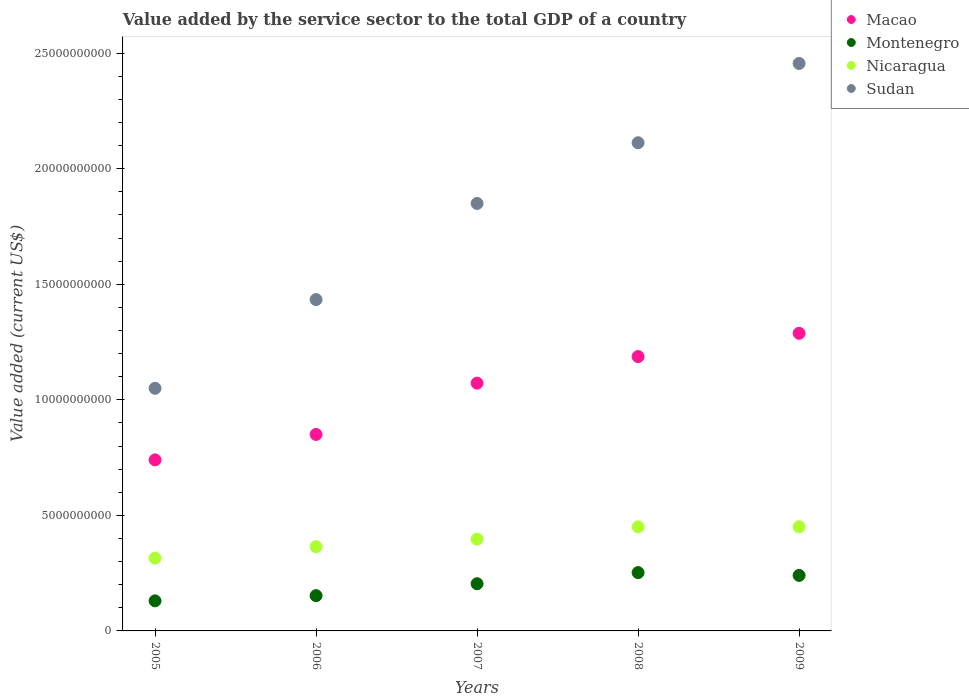How many different coloured dotlines are there?
Offer a very short reply. 4. What is the value added by the service sector to the total GDP in Sudan in 2009?
Keep it short and to the point. 2.46e+1. Across all years, what is the maximum value added by the service sector to the total GDP in Montenegro?
Provide a succinct answer. 2.52e+09. Across all years, what is the minimum value added by the service sector to the total GDP in Macao?
Ensure brevity in your answer.  7.40e+09. What is the total value added by the service sector to the total GDP in Nicaragua in the graph?
Your answer should be compact. 1.98e+1. What is the difference between the value added by the service sector to the total GDP in Nicaragua in 2005 and that in 2006?
Offer a terse response. -4.93e+08. What is the difference between the value added by the service sector to the total GDP in Nicaragua in 2006 and the value added by the service sector to the total GDP in Sudan in 2008?
Your answer should be very brief. -1.75e+1. What is the average value added by the service sector to the total GDP in Sudan per year?
Make the answer very short. 1.78e+1. In the year 2009, what is the difference between the value added by the service sector to the total GDP in Montenegro and value added by the service sector to the total GDP in Sudan?
Offer a terse response. -2.22e+1. In how many years, is the value added by the service sector to the total GDP in Sudan greater than 5000000000 US$?
Provide a short and direct response. 5. What is the ratio of the value added by the service sector to the total GDP in Sudan in 2005 to that in 2008?
Your answer should be compact. 0.5. Is the difference between the value added by the service sector to the total GDP in Montenegro in 2005 and 2006 greater than the difference between the value added by the service sector to the total GDP in Sudan in 2005 and 2006?
Ensure brevity in your answer.  Yes. What is the difference between the highest and the second highest value added by the service sector to the total GDP in Macao?
Give a very brief answer. 1.01e+09. What is the difference between the highest and the lowest value added by the service sector to the total GDP in Nicaragua?
Provide a succinct answer. 1.36e+09. In how many years, is the value added by the service sector to the total GDP in Nicaragua greater than the average value added by the service sector to the total GDP in Nicaragua taken over all years?
Offer a terse response. 3. Is the sum of the value added by the service sector to the total GDP in Sudan in 2006 and 2008 greater than the maximum value added by the service sector to the total GDP in Nicaragua across all years?
Your answer should be very brief. Yes. Is it the case that in every year, the sum of the value added by the service sector to the total GDP in Sudan and value added by the service sector to the total GDP in Macao  is greater than the sum of value added by the service sector to the total GDP in Montenegro and value added by the service sector to the total GDP in Nicaragua?
Your answer should be compact. No. Is it the case that in every year, the sum of the value added by the service sector to the total GDP in Montenegro and value added by the service sector to the total GDP in Nicaragua  is greater than the value added by the service sector to the total GDP in Sudan?
Provide a short and direct response. No. Is the value added by the service sector to the total GDP in Nicaragua strictly less than the value added by the service sector to the total GDP in Sudan over the years?
Offer a very short reply. Yes. What is the difference between two consecutive major ticks on the Y-axis?
Offer a terse response. 5.00e+09. Does the graph contain any zero values?
Provide a succinct answer. No. Does the graph contain grids?
Ensure brevity in your answer.  No. How many legend labels are there?
Make the answer very short. 4. How are the legend labels stacked?
Give a very brief answer. Vertical. What is the title of the graph?
Your response must be concise. Value added by the service sector to the total GDP of a country. What is the label or title of the Y-axis?
Offer a very short reply. Value added (current US$). What is the Value added (current US$) in Macao in 2005?
Offer a terse response. 7.40e+09. What is the Value added (current US$) of Montenegro in 2005?
Make the answer very short. 1.30e+09. What is the Value added (current US$) of Nicaragua in 2005?
Your answer should be very brief. 3.15e+09. What is the Value added (current US$) of Sudan in 2005?
Your response must be concise. 1.05e+1. What is the Value added (current US$) in Macao in 2006?
Your answer should be compact. 8.50e+09. What is the Value added (current US$) of Montenegro in 2006?
Make the answer very short. 1.53e+09. What is the Value added (current US$) in Nicaragua in 2006?
Your answer should be compact. 3.64e+09. What is the Value added (current US$) of Sudan in 2006?
Offer a terse response. 1.43e+1. What is the Value added (current US$) in Macao in 2007?
Ensure brevity in your answer.  1.07e+1. What is the Value added (current US$) of Montenegro in 2007?
Your response must be concise. 2.04e+09. What is the Value added (current US$) of Nicaragua in 2007?
Offer a very short reply. 3.97e+09. What is the Value added (current US$) of Sudan in 2007?
Ensure brevity in your answer.  1.85e+1. What is the Value added (current US$) in Macao in 2008?
Provide a short and direct response. 1.19e+1. What is the Value added (current US$) of Montenegro in 2008?
Give a very brief answer. 2.52e+09. What is the Value added (current US$) of Nicaragua in 2008?
Your answer should be very brief. 4.50e+09. What is the Value added (current US$) in Sudan in 2008?
Provide a succinct answer. 2.11e+1. What is the Value added (current US$) in Macao in 2009?
Provide a succinct answer. 1.29e+1. What is the Value added (current US$) of Montenegro in 2009?
Make the answer very short. 2.40e+09. What is the Value added (current US$) in Nicaragua in 2009?
Provide a succinct answer. 4.51e+09. What is the Value added (current US$) of Sudan in 2009?
Keep it short and to the point. 2.46e+1. Across all years, what is the maximum Value added (current US$) in Macao?
Make the answer very short. 1.29e+1. Across all years, what is the maximum Value added (current US$) of Montenegro?
Your answer should be very brief. 2.52e+09. Across all years, what is the maximum Value added (current US$) in Nicaragua?
Provide a succinct answer. 4.51e+09. Across all years, what is the maximum Value added (current US$) in Sudan?
Keep it short and to the point. 2.46e+1. Across all years, what is the minimum Value added (current US$) of Macao?
Your answer should be compact. 7.40e+09. Across all years, what is the minimum Value added (current US$) in Montenegro?
Your answer should be compact. 1.30e+09. Across all years, what is the minimum Value added (current US$) in Nicaragua?
Provide a succinct answer. 3.15e+09. Across all years, what is the minimum Value added (current US$) in Sudan?
Ensure brevity in your answer.  1.05e+1. What is the total Value added (current US$) in Macao in the graph?
Keep it short and to the point. 5.14e+1. What is the total Value added (current US$) in Montenegro in the graph?
Give a very brief answer. 9.80e+09. What is the total Value added (current US$) of Nicaragua in the graph?
Give a very brief answer. 1.98e+1. What is the total Value added (current US$) of Sudan in the graph?
Offer a terse response. 8.90e+1. What is the difference between the Value added (current US$) in Macao in 2005 and that in 2006?
Provide a succinct answer. -1.10e+09. What is the difference between the Value added (current US$) in Montenegro in 2005 and that in 2006?
Provide a succinct answer. -2.25e+08. What is the difference between the Value added (current US$) in Nicaragua in 2005 and that in 2006?
Make the answer very short. -4.93e+08. What is the difference between the Value added (current US$) in Sudan in 2005 and that in 2006?
Keep it short and to the point. -3.84e+09. What is the difference between the Value added (current US$) in Macao in 2005 and that in 2007?
Your response must be concise. -3.32e+09. What is the difference between the Value added (current US$) of Montenegro in 2005 and that in 2007?
Your answer should be compact. -7.41e+08. What is the difference between the Value added (current US$) of Nicaragua in 2005 and that in 2007?
Keep it short and to the point. -8.19e+08. What is the difference between the Value added (current US$) of Sudan in 2005 and that in 2007?
Provide a short and direct response. -8.00e+09. What is the difference between the Value added (current US$) in Macao in 2005 and that in 2008?
Offer a terse response. -4.47e+09. What is the difference between the Value added (current US$) of Montenegro in 2005 and that in 2008?
Offer a very short reply. -1.22e+09. What is the difference between the Value added (current US$) of Nicaragua in 2005 and that in 2008?
Your answer should be very brief. -1.35e+09. What is the difference between the Value added (current US$) of Sudan in 2005 and that in 2008?
Keep it short and to the point. -1.06e+1. What is the difference between the Value added (current US$) in Macao in 2005 and that in 2009?
Your response must be concise. -5.48e+09. What is the difference between the Value added (current US$) of Montenegro in 2005 and that in 2009?
Keep it short and to the point. -1.10e+09. What is the difference between the Value added (current US$) in Nicaragua in 2005 and that in 2009?
Provide a short and direct response. -1.36e+09. What is the difference between the Value added (current US$) of Sudan in 2005 and that in 2009?
Your answer should be compact. -1.41e+1. What is the difference between the Value added (current US$) in Macao in 2006 and that in 2007?
Your response must be concise. -2.22e+09. What is the difference between the Value added (current US$) of Montenegro in 2006 and that in 2007?
Give a very brief answer. -5.16e+08. What is the difference between the Value added (current US$) of Nicaragua in 2006 and that in 2007?
Your answer should be compact. -3.26e+08. What is the difference between the Value added (current US$) in Sudan in 2006 and that in 2007?
Give a very brief answer. -4.16e+09. What is the difference between the Value added (current US$) of Macao in 2006 and that in 2008?
Make the answer very short. -3.37e+09. What is the difference between the Value added (current US$) of Montenegro in 2006 and that in 2008?
Give a very brief answer. -9.96e+08. What is the difference between the Value added (current US$) of Nicaragua in 2006 and that in 2008?
Your response must be concise. -8.58e+08. What is the difference between the Value added (current US$) of Sudan in 2006 and that in 2008?
Give a very brief answer. -6.79e+09. What is the difference between the Value added (current US$) in Macao in 2006 and that in 2009?
Give a very brief answer. -4.38e+09. What is the difference between the Value added (current US$) of Montenegro in 2006 and that in 2009?
Provide a succinct answer. -8.76e+08. What is the difference between the Value added (current US$) of Nicaragua in 2006 and that in 2009?
Give a very brief answer. -8.62e+08. What is the difference between the Value added (current US$) of Sudan in 2006 and that in 2009?
Provide a short and direct response. -1.02e+1. What is the difference between the Value added (current US$) of Macao in 2007 and that in 2008?
Offer a terse response. -1.15e+09. What is the difference between the Value added (current US$) in Montenegro in 2007 and that in 2008?
Offer a terse response. -4.80e+08. What is the difference between the Value added (current US$) in Nicaragua in 2007 and that in 2008?
Give a very brief answer. -5.32e+08. What is the difference between the Value added (current US$) of Sudan in 2007 and that in 2008?
Provide a short and direct response. -2.63e+09. What is the difference between the Value added (current US$) of Macao in 2007 and that in 2009?
Provide a succinct answer. -2.16e+09. What is the difference between the Value added (current US$) in Montenegro in 2007 and that in 2009?
Your response must be concise. -3.60e+08. What is the difference between the Value added (current US$) in Nicaragua in 2007 and that in 2009?
Offer a terse response. -5.36e+08. What is the difference between the Value added (current US$) in Sudan in 2007 and that in 2009?
Ensure brevity in your answer.  -6.06e+09. What is the difference between the Value added (current US$) of Macao in 2008 and that in 2009?
Offer a very short reply. -1.01e+09. What is the difference between the Value added (current US$) in Montenegro in 2008 and that in 2009?
Provide a succinct answer. 1.20e+08. What is the difference between the Value added (current US$) in Nicaragua in 2008 and that in 2009?
Provide a succinct answer. -3.93e+06. What is the difference between the Value added (current US$) in Sudan in 2008 and that in 2009?
Keep it short and to the point. -3.43e+09. What is the difference between the Value added (current US$) in Macao in 2005 and the Value added (current US$) in Montenegro in 2006?
Make the answer very short. 5.87e+09. What is the difference between the Value added (current US$) in Macao in 2005 and the Value added (current US$) in Nicaragua in 2006?
Keep it short and to the point. 3.76e+09. What is the difference between the Value added (current US$) in Macao in 2005 and the Value added (current US$) in Sudan in 2006?
Provide a succinct answer. -6.94e+09. What is the difference between the Value added (current US$) in Montenegro in 2005 and the Value added (current US$) in Nicaragua in 2006?
Your answer should be compact. -2.34e+09. What is the difference between the Value added (current US$) in Montenegro in 2005 and the Value added (current US$) in Sudan in 2006?
Ensure brevity in your answer.  -1.30e+1. What is the difference between the Value added (current US$) in Nicaragua in 2005 and the Value added (current US$) in Sudan in 2006?
Your answer should be very brief. -1.12e+1. What is the difference between the Value added (current US$) in Macao in 2005 and the Value added (current US$) in Montenegro in 2007?
Make the answer very short. 5.36e+09. What is the difference between the Value added (current US$) of Macao in 2005 and the Value added (current US$) of Nicaragua in 2007?
Ensure brevity in your answer.  3.43e+09. What is the difference between the Value added (current US$) of Macao in 2005 and the Value added (current US$) of Sudan in 2007?
Your answer should be compact. -1.11e+1. What is the difference between the Value added (current US$) in Montenegro in 2005 and the Value added (current US$) in Nicaragua in 2007?
Offer a very short reply. -2.67e+09. What is the difference between the Value added (current US$) in Montenegro in 2005 and the Value added (current US$) in Sudan in 2007?
Your answer should be compact. -1.72e+1. What is the difference between the Value added (current US$) in Nicaragua in 2005 and the Value added (current US$) in Sudan in 2007?
Ensure brevity in your answer.  -1.53e+1. What is the difference between the Value added (current US$) of Macao in 2005 and the Value added (current US$) of Montenegro in 2008?
Ensure brevity in your answer.  4.88e+09. What is the difference between the Value added (current US$) in Macao in 2005 and the Value added (current US$) in Nicaragua in 2008?
Your answer should be very brief. 2.90e+09. What is the difference between the Value added (current US$) of Macao in 2005 and the Value added (current US$) of Sudan in 2008?
Your response must be concise. -1.37e+1. What is the difference between the Value added (current US$) in Montenegro in 2005 and the Value added (current US$) in Nicaragua in 2008?
Your response must be concise. -3.20e+09. What is the difference between the Value added (current US$) of Montenegro in 2005 and the Value added (current US$) of Sudan in 2008?
Provide a succinct answer. -1.98e+1. What is the difference between the Value added (current US$) in Nicaragua in 2005 and the Value added (current US$) in Sudan in 2008?
Ensure brevity in your answer.  -1.80e+1. What is the difference between the Value added (current US$) of Macao in 2005 and the Value added (current US$) of Montenegro in 2009?
Offer a very short reply. 5.00e+09. What is the difference between the Value added (current US$) in Macao in 2005 and the Value added (current US$) in Nicaragua in 2009?
Keep it short and to the point. 2.89e+09. What is the difference between the Value added (current US$) in Macao in 2005 and the Value added (current US$) in Sudan in 2009?
Provide a succinct answer. -1.72e+1. What is the difference between the Value added (current US$) of Montenegro in 2005 and the Value added (current US$) of Nicaragua in 2009?
Your response must be concise. -3.21e+09. What is the difference between the Value added (current US$) in Montenegro in 2005 and the Value added (current US$) in Sudan in 2009?
Keep it short and to the point. -2.33e+1. What is the difference between the Value added (current US$) in Nicaragua in 2005 and the Value added (current US$) in Sudan in 2009?
Your answer should be compact. -2.14e+1. What is the difference between the Value added (current US$) in Macao in 2006 and the Value added (current US$) in Montenegro in 2007?
Offer a very short reply. 6.46e+09. What is the difference between the Value added (current US$) of Macao in 2006 and the Value added (current US$) of Nicaragua in 2007?
Provide a short and direct response. 4.53e+09. What is the difference between the Value added (current US$) in Macao in 2006 and the Value added (current US$) in Sudan in 2007?
Ensure brevity in your answer.  -1.00e+1. What is the difference between the Value added (current US$) in Montenegro in 2006 and the Value added (current US$) in Nicaragua in 2007?
Offer a very short reply. -2.44e+09. What is the difference between the Value added (current US$) of Montenegro in 2006 and the Value added (current US$) of Sudan in 2007?
Provide a succinct answer. -1.70e+1. What is the difference between the Value added (current US$) of Nicaragua in 2006 and the Value added (current US$) of Sudan in 2007?
Your answer should be compact. -1.49e+1. What is the difference between the Value added (current US$) in Macao in 2006 and the Value added (current US$) in Montenegro in 2008?
Your response must be concise. 5.98e+09. What is the difference between the Value added (current US$) of Macao in 2006 and the Value added (current US$) of Nicaragua in 2008?
Provide a short and direct response. 4.00e+09. What is the difference between the Value added (current US$) of Macao in 2006 and the Value added (current US$) of Sudan in 2008?
Make the answer very short. -1.26e+1. What is the difference between the Value added (current US$) in Montenegro in 2006 and the Value added (current US$) in Nicaragua in 2008?
Your answer should be very brief. -2.98e+09. What is the difference between the Value added (current US$) in Montenegro in 2006 and the Value added (current US$) in Sudan in 2008?
Ensure brevity in your answer.  -1.96e+1. What is the difference between the Value added (current US$) in Nicaragua in 2006 and the Value added (current US$) in Sudan in 2008?
Make the answer very short. -1.75e+1. What is the difference between the Value added (current US$) in Macao in 2006 and the Value added (current US$) in Montenegro in 2009?
Provide a succinct answer. 6.10e+09. What is the difference between the Value added (current US$) in Macao in 2006 and the Value added (current US$) in Nicaragua in 2009?
Give a very brief answer. 4.00e+09. What is the difference between the Value added (current US$) in Macao in 2006 and the Value added (current US$) in Sudan in 2009?
Ensure brevity in your answer.  -1.61e+1. What is the difference between the Value added (current US$) of Montenegro in 2006 and the Value added (current US$) of Nicaragua in 2009?
Give a very brief answer. -2.98e+09. What is the difference between the Value added (current US$) in Montenegro in 2006 and the Value added (current US$) in Sudan in 2009?
Provide a succinct answer. -2.30e+1. What is the difference between the Value added (current US$) in Nicaragua in 2006 and the Value added (current US$) in Sudan in 2009?
Your answer should be very brief. -2.09e+1. What is the difference between the Value added (current US$) of Macao in 2007 and the Value added (current US$) of Montenegro in 2008?
Provide a short and direct response. 8.20e+09. What is the difference between the Value added (current US$) of Macao in 2007 and the Value added (current US$) of Nicaragua in 2008?
Keep it short and to the point. 6.22e+09. What is the difference between the Value added (current US$) in Macao in 2007 and the Value added (current US$) in Sudan in 2008?
Your response must be concise. -1.04e+1. What is the difference between the Value added (current US$) of Montenegro in 2007 and the Value added (current US$) of Nicaragua in 2008?
Your response must be concise. -2.46e+09. What is the difference between the Value added (current US$) in Montenegro in 2007 and the Value added (current US$) in Sudan in 2008?
Your answer should be very brief. -1.91e+1. What is the difference between the Value added (current US$) in Nicaragua in 2007 and the Value added (current US$) in Sudan in 2008?
Your answer should be compact. -1.72e+1. What is the difference between the Value added (current US$) in Macao in 2007 and the Value added (current US$) in Montenegro in 2009?
Your answer should be very brief. 8.32e+09. What is the difference between the Value added (current US$) in Macao in 2007 and the Value added (current US$) in Nicaragua in 2009?
Your answer should be very brief. 6.21e+09. What is the difference between the Value added (current US$) of Macao in 2007 and the Value added (current US$) of Sudan in 2009?
Make the answer very short. -1.38e+1. What is the difference between the Value added (current US$) in Montenegro in 2007 and the Value added (current US$) in Nicaragua in 2009?
Offer a very short reply. -2.46e+09. What is the difference between the Value added (current US$) in Montenegro in 2007 and the Value added (current US$) in Sudan in 2009?
Make the answer very short. -2.25e+1. What is the difference between the Value added (current US$) of Nicaragua in 2007 and the Value added (current US$) of Sudan in 2009?
Your answer should be compact. -2.06e+1. What is the difference between the Value added (current US$) in Macao in 2008 and the Value added (current US$) in Montenegro in 2009?
Your answer should be very brief. 9.47e+09. What is the difference between the Value added (current US$) of Macao in 2008 and the Value added (current US$) of Nicaragua in 2009?
Your response must be concise. 7.36e+09. What is the difference between the Value added (current US$) of Macao in 2008 and the Value added (current US$) of Sudan in 2009?
Keep it short and to the point. -1.27e+1. What is the difference between the Value added (current US$) in Montenegro in 2008 and the Value added (current US$) in Nicaragua in 2009?
Provide a succinct answer. -1.98e+09. What is the difference between the Value added (current US$) of Montenegro in 2008 and the Value added (current US$) of Sudan in 2009?
Provide a short and direct response. -2.20e+1. What is the difference between the Value added (current US$) of Nicaragua in 2008 and the Value added (current US$) of Sudan in 2009?
Offer a terse response. -2.01e+1. What is the average Value added (current US$) of Macao per year?
Give a very brief answer. 1.03e+1. What is the average Value added (current US$) in Montenegro per year?
Provide a succinct answer. 1.96e+09. What is the average Value added (current US$) in Nicaragua per year?
Your answer should be compact. 3.96e+09. What is the average Value added (current US$) in Sudan per year?
Offer a terse response. 1.78e+1. In the year 2005, what is the difference between the Value added (current US$) in Macao and Value added (current US$) in Montenegro?
Give a very brief answer. 6.10e+09. In the year 2005, what is the difference between the Value added (current US$) in Macao and Value added (current US$) in Nicaragua?
Offer a terse response. 4.25e+09. In the year 2005, what is the difference between the Value added (current US$) in Macao and Value added (current US$) in Sudan?
Your response must be concise. -3.10e+09. In the year 2005, what is the difference between the Value added (current US$) of Montenegro and Value added (current US$) of Nicaragua?
Offer a terse response. -1.85e+09. In the year 2005, what is the difference between the Value added (current US$) in Montenegro and Value added (current US$) in Sudan?
Keep it short and to the point. -9.20e+09. In the year 2005, what is the difference between the Value added (current US$) in Nicaragua and Value added (current US$) in Sudan?
Provide a succinct answer. -7.35e+09. In the year 2006, what is the difference between the Value added (current US$) of Macao and Value added (current US$) of Montenegro?
Keep it short and to the point. 6.98e+09. In the year 2006, what is the difference between the Value added (current US$) of Macao and Value added (current US$) of Nicaragua?
Keep it short and to the point. 4.86e+09. In the year 2006, what is the difference between the Value added (current US$) of Macao and Value added (current US$) of Sudan?
Your answer should be very brief. -5.84e+09. In the year 2006, what is the difference between the Value added (current US$) of Montenegro and Value added (current US$) of Nicaragua?
Offer a very short reply. -2.12e+09. In the year 2006, what is the difference between the Value added (current US$) of Montenegro and Value added (current US$) of Sudan?
Your answer should be very brief. -1.28e+1. In the year 2006, what is the difference between the Value added (current US$) of Nicaragua and Value added (current US$) of Sudan?
Your response must be concise. -1.07e+1. In the year 2007, what is the difference between the Value added (current US$) of Macao and Value added (current US$) of Montenegro?
Give a very brief answer. 8.68e+09. In the year 2007, what is the difference between the Value added (current US$) of Macao and Value added (current US$) of Nicaragua?
Provide a succinct answer. 6.75e+09. In the year 2007, what is the difference between the Value added (current US$) of Macao and Value added (current US$) of Sudan?
Your answer should be compact. -7.78e+09. In the year 2007, what is the difference between the Value added (current US$) of Montenegro and Value added (current US$) of Nicaragua?
Your answer should be very brief. -1.93e+09. In the year 2007, what is the difference between the Value added (current US$) in Montenegro and Value added (current US$) in Sudan?
Your response must be concise. -1.65e+1. In the year 2007, what is the difference between the Value added (current US$) of Nicaragua and Value added (current US$) of Sudan?
Your answer should be compact. -1.45e+1. In the year 2008, what is the difference between the Value added (current US$) in Macao and Value added (current US$) in Montenegro?
Provide a short and direct response. 9.35e+09. In the year 2008, what is the difference between the Value added (current US$) in Macao and Value added (current US$) in Nicaragua?
Ensure brevity in your answer.  7.37e+09. In the year 2008, what is the difference between the Value added (current US$) of Macao and Value added (current US$) of Sudan?
Your response must be concise. -9.25e+09. In the year 2008, what is the difference between the Value added (current US$) of Montenegro and Value added (current US$) of Nicaragua?
Provide a succinct answer. -1.98e+09. In the year 2008, what is the difference between the Value added (current US$) of Montenegro and Value added (current US$) of Sudan?
Offer a terse response. -1.86e+1. In the year 2008, what is the difference between the Value added (current US$) of Nicaragua and Value added (current US$) of Sudan?
Your answer should be very brief. -1.66e+1. In the year 2009, what is the difference between the Value added (current US$) in Macao and Value added (current US$) in Montenegro?
Your answer should be very brief. 1.05e+1. In the year 2009, what is the difference between the Value added (current US$) in Macao and Value added (current US$) in Nicaragua?
Offer a very short reply. 8.37e+09. In the year 2009, what is the difference between the Value added (current US$) in Macao and Value added (current US$) in Sudan?
Your answer should be very brief. -1.17e+1. In the year 2009, what is the difference between the Value added (current US$) of Montenegro and Value added (current US$) of Nicaragua?
Provide a succinct answer. -2.10e+09. In the year 2009, what is the difference between the Value added (current US$) of Montenegro and Value added (current US$) of Sudan?
Your answer should be compact. -2.22e+1. In the year 2009, what is the difference between the Value added (current US$) of Nicaragua and Value added (current US$) of Sudan?
Ensure brevity in your answer.  -2.00e+1. What is the ratio of the Value added (current US$) of Macao in 2005 to that in 2006?
Offer a very short reply. 0.87. What is the ratio of the Value added (current US$) in Montenegro in 2005 to that in 2006?
Your answer should be compact. 0.85. What is the ratio of the Value added (current US$) of Nicaragua in 2005 to that in 2006?
Offer a terse response. 0.86. What is the ratio of the Value added (current US$) of Sudan in 2005 to that in 2006?
Offer a very short reply. 0.73. What is the ratio of the Value added (current US$) in Macao in 2005 to that in 2007?
Your answer should be very brief. 0.69. What is the ratio of the Value added (current US$) in Montenegro in 2005 to that in 2007?
Provide a succinct answer. 0.64. What is the ratio of the Value added (current US$) in Nicaragua in 2005 to that in 2007?
Provide a short and direct response. 0.79. What is the ratio of the Value added (current US$) of Sudan in 2005 to that in 2007?
Make the answer very short. 0.57. What is the ratio of the Value added (current US$) in Macao in 2005 to that in 2008?
Offer a very short reply. 0.62. What is the ratio of the Value added (current US$) of Montenegro in 2005 to that in 2008?
Your response must be concise. 0.52. What is the ratio of the Value added (current US$) in Nicaragua in 2005 to that in 2008?
Give a very brief answer. 0.7. What is the ratio of the Value added (current US$) in Sudan in 2005 to that in 2008?
Provide a short and direct response. 0.5. What is the ratio of the Value added (current US$) of Macao in 2005 to that in 2009?
Your response must be concise. 0.57. What is the ratio of the Value added (current US$) in Montenegro in 2005 to that in 2009?
Ensure brevity in your answer.  0.54. What is the ratio of the Value added (current US$) in Nicaragua in 2005 to that in 2009?
Offer a terse response. 0.7. What is the ratio of the Value added (current US$) in Sudan in 2005 to that in 2009?
Offer a very short reply. 0.43. What is the ratio of the Value added (current US$) in Macao in 2006 to that in 2007?
Your answer should be very brief. 0.79. What is the ratio of the Value added (current US$) of Montenegro in 2006 to that in 2007?
Ensure brevity in your answer.  0.75. What is the ratio of the Value added (current US$) in Nicaragua in 2006 to that in 2007?
Ensure brevity in your answer.  0.92. What is the ratio of the Value added (current US$) in Sudan in 2006 to that in 2007?
Offer a very short reply. 0.78. What is the ratio of the Value added (current US$) in Macao in 2006 to that in 2008?
Your response must be concise. 0.72. What is the ratio of the Value added (current US$) of Montenegro in 2006 to that in 2008?
Your response must be concise. 0.61. What is the ratio of the Value added (current US$) of Nicaragua in 2006 to that in 2008?
Your answer should be very brief. 0.81. What is the ratio of the Value added (current US$) of Sudan in 2006 to that in 2008?
Your answer should be compact. 0.68. What is the ratio of the Value added (current US$) of Macao in 2006 to that in 2009?
Give a very brief answer. 0.66. What is the ratio of the Value added (current US$) of Montenegro in 2006 to that in 2009?
Give a very brief answer. 0.64. What is the ratio of the Value added (current US$) of Nicaragua in 2006 to that in 2009?
Provide a short and direct response. 0.81. What is the ratio of the Value added (current US$) in Sudan in 2006 to that in 2009?
Keep it short and to the point. 0.58. What is the ratio of the Value added (current US$) in Macao in 2007 to that in 2008?
Keep it short and to the point. 0.9. What is the ratio of the Value added (current US$) of Montenegro in 2007 to that in 2008?
Offer a very short reply. 0.81. What is the ratio of the Value added (current US$) of Nicaragua in 2007 to that in 2008?
Your answer should be compact. 0.88. What is the ratio of the Value added (current US$) in Sudan in 2007 to that in 2008?
Your answer should be compact. 0.88. What is the ratio of the Value added (current US$) in Macao in 2007 to that in 2009?
Your answer should be very brief. 0.83. What is the ratio of the Value added (current US$) of Montenegro in 2007 to that in 2009?
Keep it short and to the point. 0.85. What is the ratio of the Value added (current US$) of Nicaragua in 2007 to that in 2009?
Give a very brief answer. 0.88. What is the ratio of the Value added (current US$) of Sudan in 2007 to that in 2009?
Keep it short and to the point. 0.75. What is the ratio of the Value added (current US$) of Macao in 2008 to that in 2009?
Your answer should be compact. 0.92. What is the ratio of the Value added (current US$) in Montenegro in 2008 to that in 2009?
Keep it short and to the point. 1.05. What is the ratio of the Value added (current US$) of Nicaragua in 2008 to that in 2009?
Make the answer very short. 1. What is the ratio of the Value added (current US$) of Sudan in 2008 to that in 2009?
Your answer should be very brief. 0.86. What is the difference between the highest and the second highest Value added (current US$) in Macao?
Ensure brevity in your answer.  1.01e+09. What is the difference between the highest and the second highest Value added (current US$) in Montenegro?
Provide a succinct answer. 1.20e+08. What is the difference between the highest and the second highest Value added (current US$) in Nicaragua?
Offer a very short reply. 3.93e+06. What is the difference between the highest and the second highest Value added (current US$) in Sudan?
Offer a terse response. 3.43e+09. What is the difference between the highest and the lowest Value added (current US$) in Macao?
Your response must be concise. 5.48e+09. What is the difference between the highest and the lowest Value added (current US$) of Montenegro?
Your answer should be very brief. 1.22e+09. What is the difference between the highest and the lowest Value added (current US$) in Nicaragua?
Provide a succinct answer. 1.36e+09. What is the difference between the highest and the lowest Value added (current US$) of Sudan?
Offer a very short reply. 1.41e+1. 